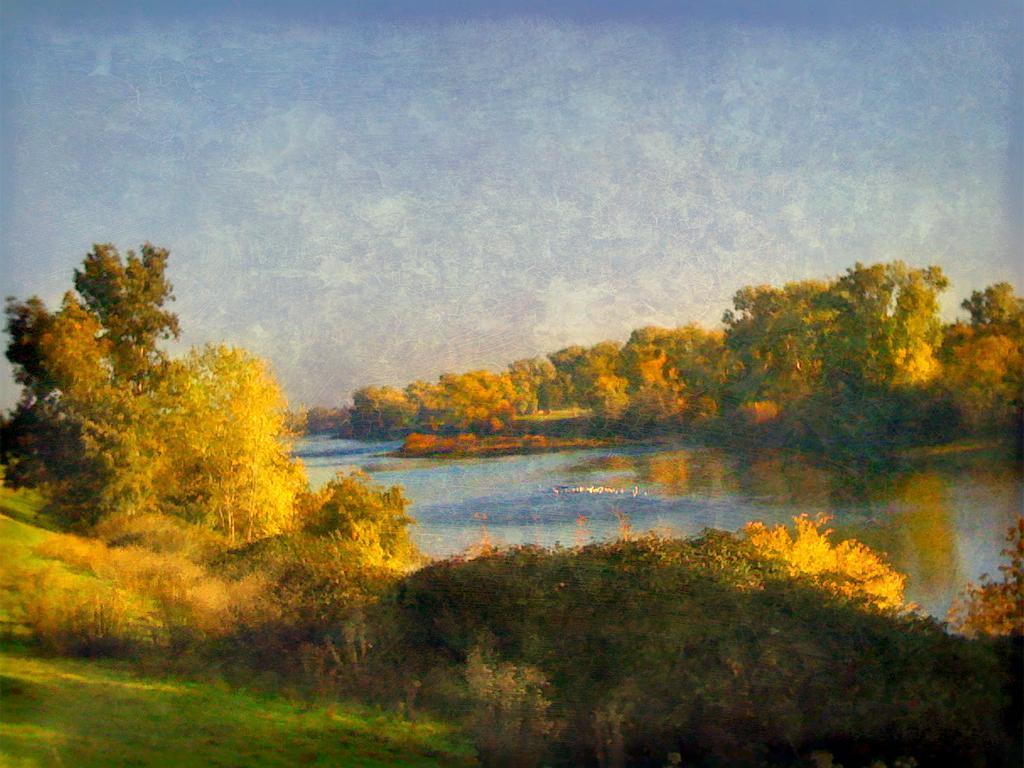Could you give a brief overview of what you see in this image? In this picture we can see some trees and plants. We can see some grass on the ground. There is water. 